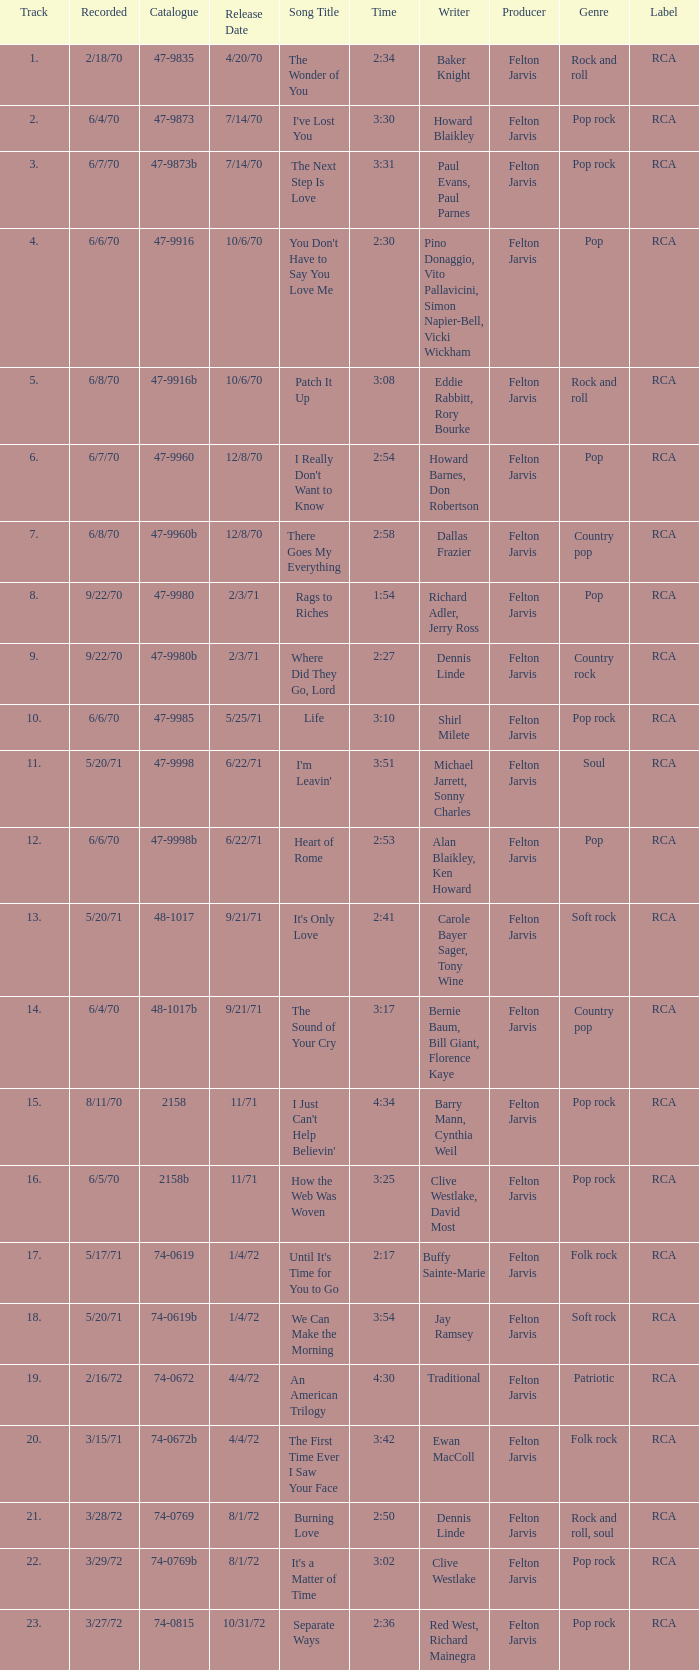Would you mind parsing the complete table? {'header': ['Track', 'Recorded', 'Catalogue', 'Release Date', 'Song Title', 'Time', 'Writer', 'Producer', 'Genre', 'Label'], 'rows': [['1.', '2/18/70', '47-9835', '4/20/70', 'The Wonder of You', '2:34', 'Baker Knight', 'Felton Jarvis', 'Rock and roll', 'RCA'], ['2.', '6/4/70', '47-9873', '7/14/70', "I've Lost You", '3:30', 'Howard Blaikley', 'Felton Jarvis', 'Pop rock', 'RCA'], ['3.', '6/7/70', '47-9873b', '7/14/70', 'The Next Step Is Love', '3:31', 'Paul Evans, Paul Parnes', 'Felton Jarvis', 'Pop rock', 'RCA'], ['4.', '6/6/70', '47-9916', '10/6/70', "You Don't Have to Say You Love Me", '2:30', 'Pino Donaggio, Vito Pallavicini, Simon Napier-Bell, Vicki Wickham', 'Felton Jarvis', 'Pop', 'RCA'], ['5.', '6/8/70', '47-9916b', '10/6/70', 'Patch It Up', '3:08', 'Eddie Rabbitt, Rory Bourke', 'Felton Jarvis', 'Rock and roll', 'RCA'], ['6.', '6/7/70', '47-9960', '12/8/70', "I Really Don't Want to Know", '2:54', 'Howard Barnes, Don Robertson', 'Felton Jarvis', 'Pop', 'RCA'], ['7.', '6/8/70', '47-9960b', '12/8/70', 'There Goes My Everything', '2:58', 'Dallas Frazier', 'Felton Jarvis', 'Country pop', 'RCA'], ['8.', '9/22/70', '47-9980', '2/3/71', 'Rags to Riches', '1:54', 'Richard Adler, Jerry Ross', 'Felton Jarvis', 'Pop', 'RCA'], ['9.', '9/22/70', '47-9980b', '2/3/71', 'Where Did They Go, Lord', '2:27', 'Dennis Linde', 'Felton Jarvis', 'Country rock', 'RCA'], ['10.', '6/6/70', '47-9985', '5/25/71', 'Life', '3:10', 'Shirl Milete', 'Felton Jarvis', 'Pop rock', 'RCA'], ['11.', '5/20/71', '47-9998', '6/22/71', "I'm Leavin'", '3:51', 'Michael Jarrett, Sonny Charles', 'Felton Jarvis', 'Soul', 'RCA'], ['12.', '6/6/70', '47-9998b', '6/22/71', 'Heart of Rome', '2:53', 'Alan Blaikley, Ken Howard', 'Felton Jarvis', 'Pop', 'RCA'], ['13.', '5/20/71', '48-1017', '9/21/71', "It's Only Love", '2:41', 'Carole Bayer Sager, Tony Wine', 'Felton Jarvis', 'Soft rock', 'RCA'], ['14.', '6/4/70', '48-1017b', '9/21/71', 'The Sound of Your Cry', '3:17', 'Bernie Baum, Bill Giant, Florence Kaye', 'Felton Jarvis', 'Country pop', 'RCA'], ['15.', '8/11/70', '2158', '11/71', "I Just Can't Help Believin'", '4:34', 'Barry Mann, Cynthia Weil', 'Felton Jarvis', 'Pop rock', 'RCA'], ['16.', '6/5/70', '2158b', '11/71', 'How the Web Was Woven', '3:25', 'Clive Westlake, David Most', 'Felton Jarvis', 'Pop rock', 'RCA'], ['17.', '5/17/71', '74-0619', '1/4/72', "Until It's Time for You to Go", '2:17', 'Buffy Sainte-Marie', 'Felton Jarvis', 'Folk rock', 'RCA'], ['18.', '5/20/71', '74-0619b', '1/4/72', 'We Can Make the Morning', '3:54', 'Jay Ramsey', 'Felton Jarvis', 'Soft rock', 'RCA'], ['19.', '2/16/72', '74-0672', '4/4/72', 'An American Trilogy', '4:30', 'Traditional', 'Felton Jarvis', 'Patriotic', 'RCA'], ['20.', '3/15/71', '74-0672b', '4/4/72', 'The First Time Ever I Saw Your Face', '3:42', 'Ewan MacColl', 'Felton Jarvis', 'Folk rock', 'RCA'], ['21.', '3/28/72', '74-0769', '8/1/72', 'Burning Love', '2:50', 'Dennis Linde', 'Felton Jarvis', 'Rock and roll, soul', 'RCA'], ['22.', '3/29/72', '74-0769b', '8/1/72', "It's a Matter of Time", '3:02', 'Clive Westlake', 'Felton Jarvis', 'Pop rock', 'RCA'], ['23.', '3/27/72', '74-0815', '10/31/72', 'Separate Ways', '2:36', 'Red West, Richard Mainegra', 'Felton Jarvis', 'Pop rock', 'RCA']]} Which song was released 12/8/70 with a time of 2:54? I Really Don't Want to Know. 